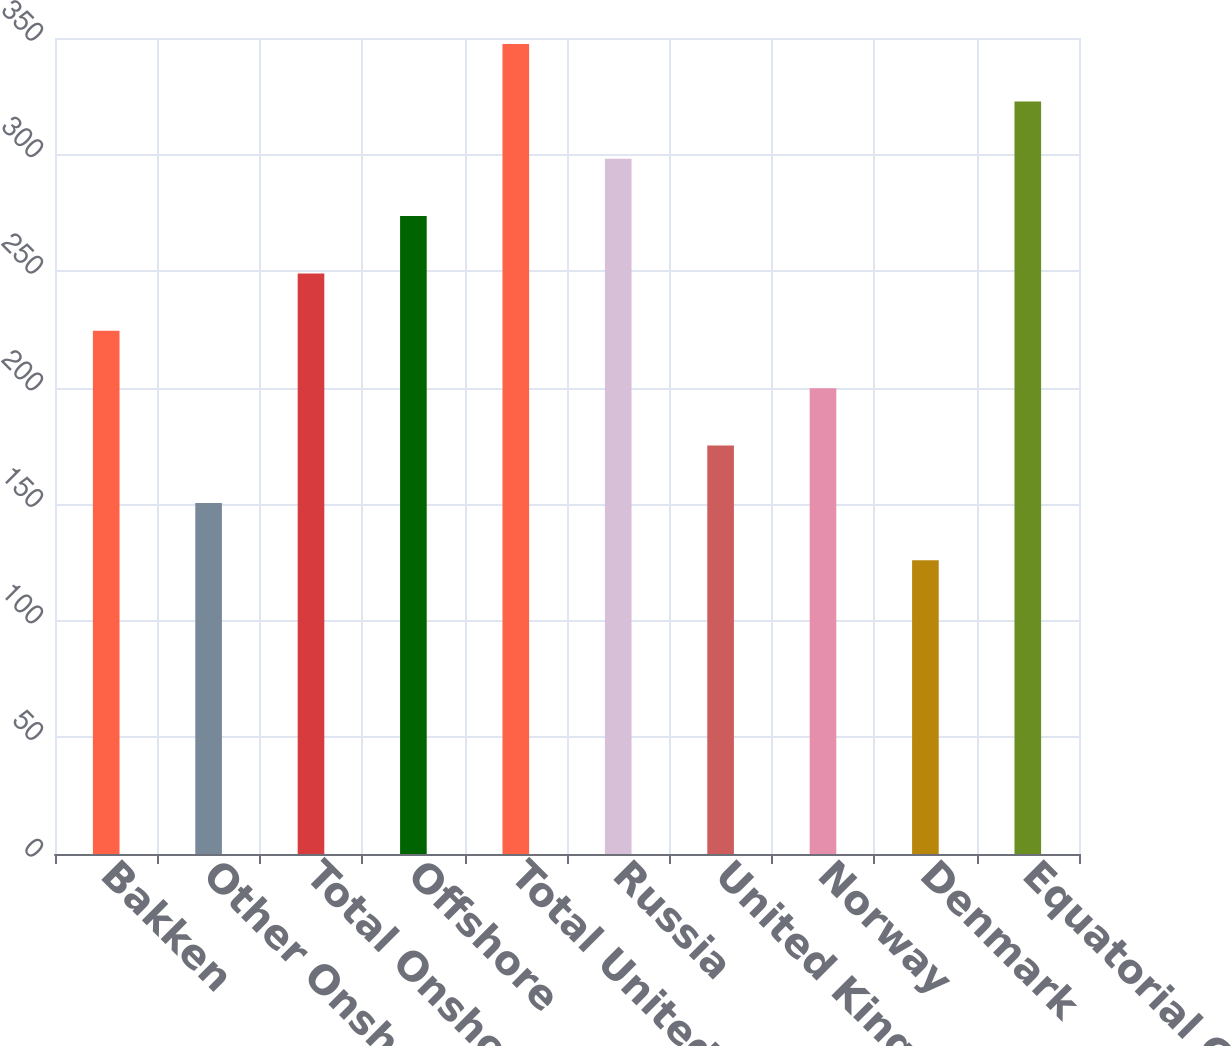Convert chart to OTSL. <chart><loc_0><loc_0><loc_500><loc_500><bar_chart><fcel>Bakken<fcel>Other Onshore<fcel>Total Onshore<fcel>Offshore<fcel>Total United States<fcel>Russia<fcel>United Kingdom<fcel>Norway<fcel>Denmark<fcel>Equatorial Guinea<nl><fcel>224.4<fcel>150.6<fcel>249<fcel>273.6<fcel>347.4<fcel>298.2<fcel>175.2<fcel>199.8<fcel>126<fcel>322.8<nl></chart> 